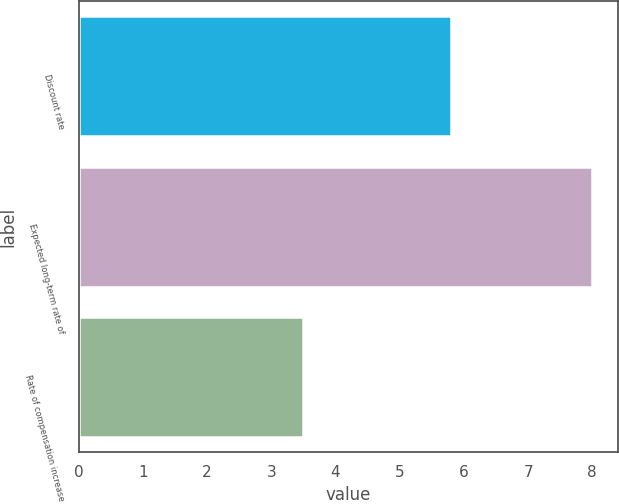Convert chart to OTSL. <chart><loc_0><loc_0><loc_500><loc_500><bar_chart><fcel>Discount rate<fcel>Expected long-term rate of<fcel>Rate of compensation increase<nl><fcel>5.8<fcel>8<fcel>3.5<nl></chart> 